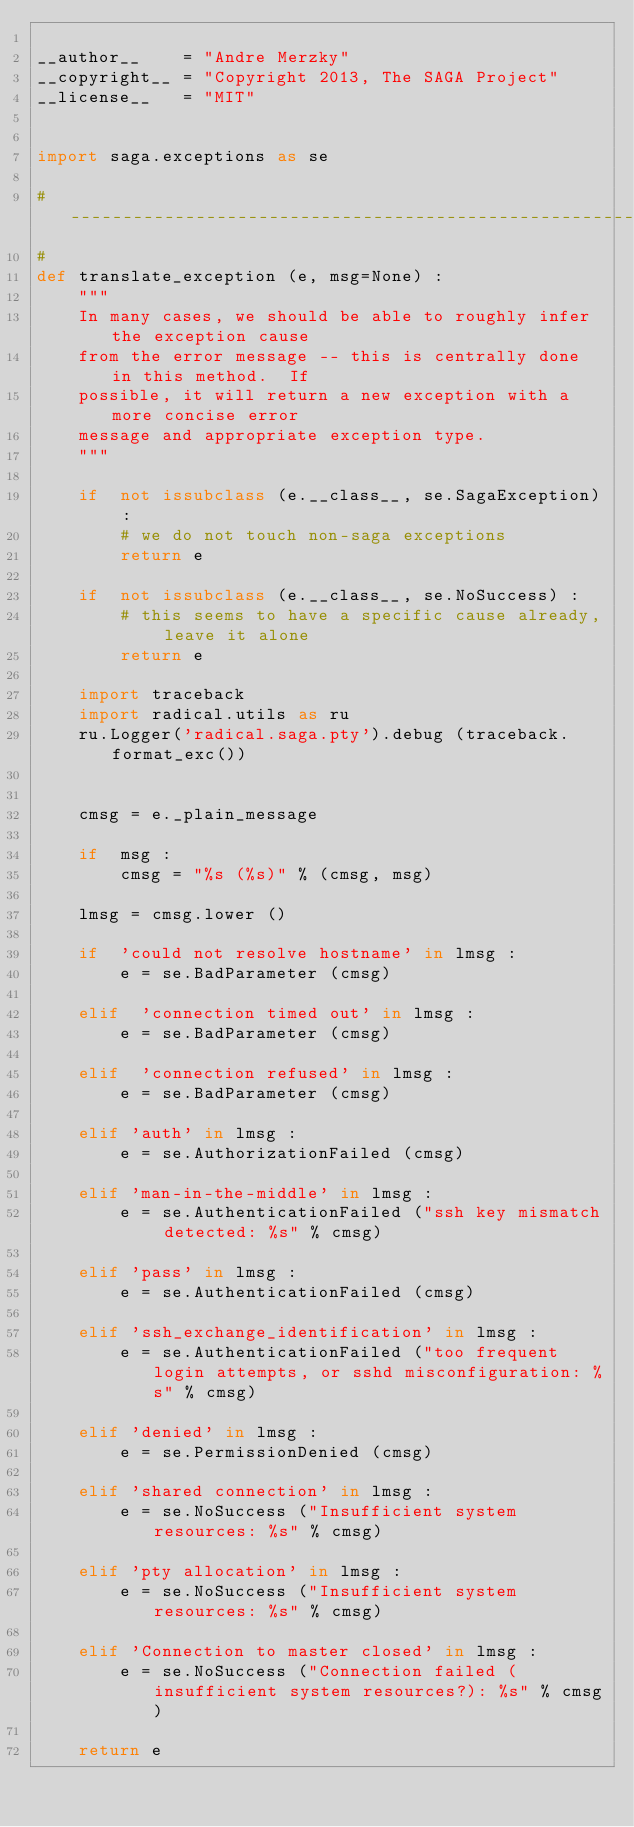<code> <loc_0><loc_0><loc_500><loc_500><_Python_>
__author__    = "Andre Merzky"
__copyright__ = "Copyright 2013, The SAGA Project"
__license__   = "MIT"


import saga.exceptions as se

# ----------------------------------------------------------------
#
def translate_exception (e, msg=None) :
    """
    In many cases, we should be able to roughly infer the exception cause
    from the error message -- this is centrally done in this method.  If
    possible, it will return a new exception with a more concise error
    message and appropriate exception type.
    """

    if  not issubclass (e.__class__, se.SagaException) :
        # we do not touch non-saga exceptions
        return e

    if  not issubclass (e.__class__, se.NoSuccess) :
        # this seems to have a specific cause already, leave it alone
        return e

    import traceback
    import radical.utils as ru
    ru.Logger('radical.saga.pty').debug (traceback.format_exc())


    cmsg = e._plain_message

    if  msg :
        cmsg = "%s (%s)" % (cmsg, msg)

    lmsg = cmsg.lower ()

    if  'could not resolve hostname' in lmsg :
        e = se.BadParameter (cmsg)

    elif  'connection timed out' in lmsg :
        e = se.BadParameter (cmsg)

    elif  'connection refused' in lmsg :
        e = se.BadParameter (cmsg)

    elif 'auth' in lmsg :
        e = se.AuthorizationFailed (cmsg)

    elif 'man-in-the-middle' in lmsg :
        e = se.AuthenticationFailed ("ssh key mismatch detected: %s" % cmsg)

    elif 'pass' in lmsg :
        e = se.AuthenticationFailed (cmsg)

    elif 'ssh_exchange_identification' in lmsg :
        e = se.AuthenticationFailed ("too frequent login attempts, or sshd misconfiguration: %s" % cmsg)

    elif 'denied' in lmsg :
        e = se.PermissionDenied (cmsg)

    elif 'shared connection' in lmsg :
        e = se.NoSuccess ("Insufficient system resources: %s" % cmsg)

    elif 'pty allocation' in lmsg :
        e = se.NoSuccess ("Insufficient system resources: %s" % cmsg)

    elif 'Connection to master closed' in lmsg :
        e = se.NoSuccess ("Connection failed (insufficient system resources?): %s" % cmsg)

    return e

</code> 